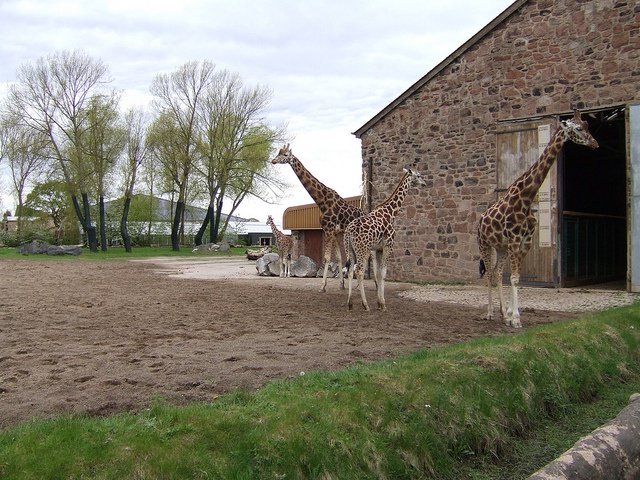Describe the objects in this image and their specific colors. I can see giraffe in lavender, black, gray, and maroon tones, giraffe in lavender, gray, darkgray, and black tones, giraffe in lavender, gray, black, and maroon tones, and giraffe in lavender, gray, darkgray, and maroon tones in this image. 